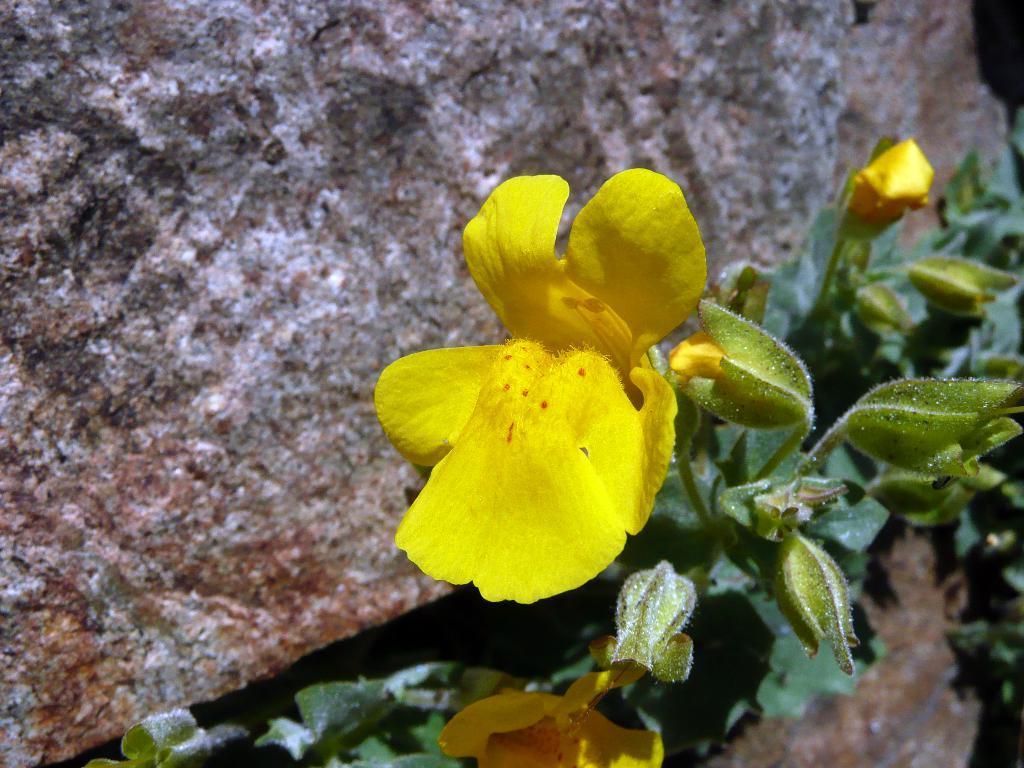In one or two sentences, can you explain what this image depicts? In this picture we can see there are plants with yellow flowers and buds. On the left side of the flowers, it looks like a rock. 